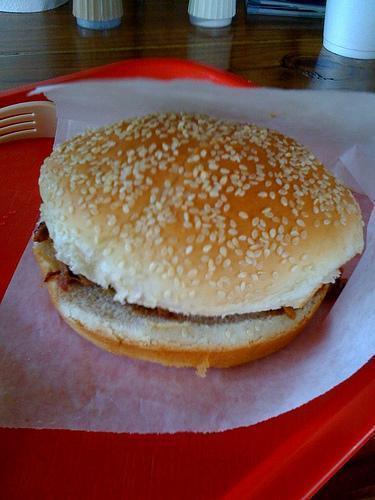What is on top of the bun?
Answer the question by selecting the correct answer among the 4 following choices.
Options: Seeds, cheese, ketchup, nachos. Seeds. 